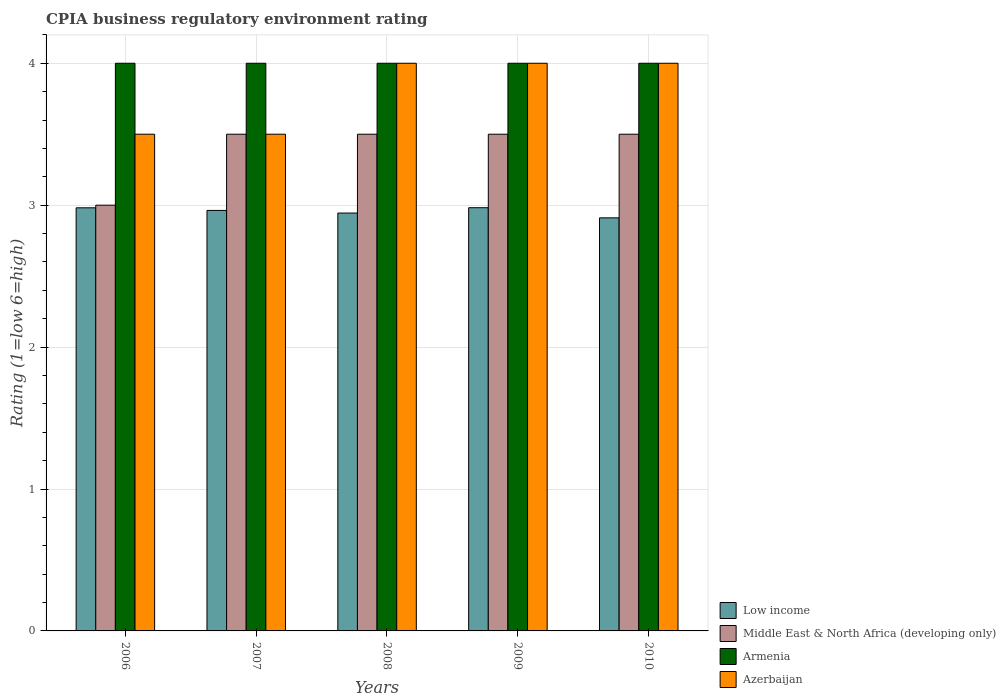How many different coloured bars are there?
Provide a succinct answer. 4. How many groups of bars are there?
Keep it short and to the point. 5. How many bars are there on the 1st tick from the left?
Your answer should be very brief. 4. What is the CPIA rating in Azerbaijan in 2010?
Your answer should be compact. 4. Across all years, what is the minimum CPIA rating in Middle East & North Africa (developing only)?
Your answer should be compact. 3. In which year was the CPIA rating in Azerbaijan maximum?
Provide a succinct answer. 2008. What is the total CPIA rating in Azerbaijan in the graph?
Your response must be concise. 19. What is the difference between the CPIA rating in Low income in 2007 and the CPIA rating in Middle East & North Africa (developing only) in 2010?
Offer a very short reply. -0.54. In the year 2006, what is the difference between the CPIA rating in Low income and CPIA rating in Middle East & North Africa (developing only)?
Provide a short and direct response. -0.02. What is the ratio of the CPIA rating in Azerbaijan in 2007 to that in 2010?
Give a very brief answer. 0.88. Is the difference between the CPIA rating in Low income in 2006 and 2007 greater than the difference between the CPIA rating in Middle East & North Africa (developing only) in 2006 and 2007?
Offer a terse response. Yes. What is the difference between the highest and the second highest CPIA rating in Low income?
Make the answer very short. 0. What does the 4th bar from the left in 2006 represents?
Provide a short and direct response. Azerbaijan. How many bars are there?
Provide a succinct answer. 20. Are all the bars in the graph horizontal?
Make the answer very short. No. How many years are there in the graph?
Give a very brief answer. 5. What is the difference between two consecutive major ticks on the Y-axis?
Offer a very short reply. 1. Are the values on the major ticks of Y-axis written in scientific E-notation?
Your answer should be very brief. No. What is the title of the graph?
Provide a short and direct response. CPIA business regulatory environment rating. What is the Rating (1=low 6=high) in Low income in 2006?
Your answer should be compact. 2.98. What is the Rating (1=low 6=high) in Armenia in 2006?
Give a very brief answer. 4. What is the Rating (1=low 6=high) of Low income in 2007?
Make the answer very short. 2.96. What is the Rating (1=low 6=high) in Middle East & North Africa (developing only) in 2007?
Make the answer very short. 3.5. What is the Rating (1=low 6=high) in Low income in 2008?
Ensure brevity in your answer.  2.94. What is the Rating (1=low 6=high) of Low income in 2009?
Provide a succinct answer. 2.98. What is the Rating (1=low 6=high) in Middle East & North Africa (developing only) in 2009?
Offer a terse response. 3.5. What is the Rating (1=low 6=high) of Azerbaijan in 2009?
Offer a very short reply. 4. What is the Rating (1=low 6=high) of Low income in 2010?
Ensure brevity in your answer.  2.91. Across all years, what is the maximum Rating (1=low 6=high) of Low income?
Keep it short and to the point. 2.98. Across all years, what is the maximum Rating (1=low 6=high) of Middle East & North Africa (developing only)?
Provide a succinct answer. 3.5. Across all years, what is the maximum Rating (1=low 6=high) of Armenia?
Your answer should be very brief. 4. Across all years, what is the minimum Rating (1=low 6=high) in Low income?
Your answer should be very brief. 2.91. Across all years, what is the minimum Rating (1=low 6=high) in Middle East & North Africa (developing only)?
Offer a very short reply. 3. What is the total Rating (1=low 6=high) of Low income in the graph?
Ensure brevity in your answer.  14.78. What is the total Rating (1=low 6=high) of Middle East & North Africa (developing only) in the graph?
Provide a short and direct response. 17. What is the total Rating (1=low 6=high) in Azerbaijan in the graph?
Offer a terse response. 19. What is the difference between the Rating (1=low 6=high) in Low income in 2006 and that in 2007?
Make the answer very short. 0.02. What is the difference between the Rating (1=low 6=high) of Middle East & North Africa (developing only) in 2006 and that in 2007?
Ensure brevity in your answer.  -0.5. What is the difference between the Rating (1=low 6=high) in Armenia in 2006 and that in 2007?
Your answer should be compact. 0. What is the difference between the Rating (1=low 6=high) of Low income in 2006 and that in 2008?
Provide a short and direct response. 0.04. What is the difference between the Rating (1=low 6=high) in Azerbaijan in 2006 and that in 2008?
Offer a very short reply. -0.5. What is the difference between the Rating (1=low 6=high) of Low income in 2006 and that in 2009?
Give a very brief answer. -0. What is the difference between the Rating (1=low 6=high) of Middle East & North Africa (developing only) in 2006 and that in 2009?
Offer a terse response. -0.5. What is the difference between the Rating (1=low 6=high) in Armenia in 2006 and that in 2009?
Provide a short and direct response. 0. What is the difference between the Rating (1=low 6=high) in Low income in 2006 and that in 2010?
Ensure brevity in your answer.  0.07. What is the difference between the Rating (1=low 6=high) of Low income in 2007 and that in 2008?
Give a very brief answer. 0.02. What is the difference between the Rating (1=low 6=high) of Middle East & North Africa (developing only) in 2007 and that in 2008?
Give a very brief answer. 0. What is the difference between the Rating (1=low 6=high) in Azerbaijan in 2007 and that in 2008?
Offer a terse response. -0.5. What is the difference between the Rating (1=low 6=high) of Low income in 2007 and that in 2009?
Make the answer very short. -0.02. What is the difference between the Rating (1=low 6=high) of Middle East & North Africa (developing only) in 2007 and that in 2009?
Provide a short and direct response. 0. What is the difference between the Rating (1=low 6=high) of Armenia in 2007 and that in 2009?
Ensure brevity in your answer.  0. What is the difference between the Rating (1=low 6=high) of Azerbaijan in 2007 and that in 2009?
Keep it short and to the point. -0.5. What is the difference between the Rating (1=low 6=high) in Low income in 2007 and that in 2010?
Your answer should be compact. 0.05. What is the difference between the Rating (1=low 6=high) of Low income in 2008 and that in 2009?
Your response must be concise. -0.04. What is the difference between the Rating (1=low 6=high) of Low income in 2008 and that in 2010?
Give a very brief answer. 0.03. What is the difference between the Rating (1=low 6=high) of Low income in 2009 and that in 2010?
Provide a succinct answer. 0.07. What is the difference between the Rating (1=low 6=high) in Middle East & North Africa (developing only) in 2009 and that in 2010?
Provide a succinct answer. 0. What is the difference between the Rating (1=low 6=high) in Azerbaijan in 2009 and that in 2010?
Provide a short and direct response. 0. What is the difference between the Rating (1=low 6=high) of Low income in 2006 and the Rating (1=low 6=high) of Middle East & North Africa (developing only) in 2007?
Provide a short and direct response. -0.52. What is the difference between the Rating (1=low 6=high) in Low income in 2006 and the Rating (1=low 6=high) in Armenia in 2007?
Your answer should be compact. -1.02. What is the difference between the Rating (1=low 6=high) of Low income in 2006 and the Rating (1=low 6=high) of Azerbaijan in 2007?
Provide a succinct answer. -0.52. What is the difference between the Rating (1=low 6=high) in Middle East & North Africa (developing only) in 2006 and the Rating (1=low 6=high) in Armenia in 2007?
Ensure brevity in your answer.  -1. What is the difference between the Rating (1=low 6=high) of Armenia in 2006 and the Rating (1=low 6=high) of Azerbaijan in 2007?
Offer a very short reply. 0.5. What is the difference between the Rating (1=low 6=high) in Low income in 2006 and the Rating (1=low 6=high) in Middle East & North Africa (developing only) in 2008?
Your response must be concise. -0.52. What is the difference between the Rating (1=low 6=high) in Low income in 2006 and the Rating (1=low 6=high) in Armenia in 2008?
Provide a short and direct response. -1.02. What is the difference between the Rating (1=low 6=high) of Low income in 2006 and the Rating (1=low 6=high) of Azerbaijan in 2008?
Offer a very short reply. -1.02. What is the difference between the Rating (1=low 6=high) of Middle East & North Africa (developing only) in 2006 and the Rating (1=low 6=high) of Azerbaijan in 2008?
Your answer should be very brief. -1. What is the difference between the Rating (1=low 6=high) in Low income in 2006 and the Rating (1=low 6=high) in Middle East & North Africa (developing only) in 2009?
Your answer should be compact. -0.52. What is the difference between the Rating (1=low 6=high) of Low income in 2006 and the Rating (1=low 6=high) of Armenia in 2009?
Ensure brevity in your answer.  -1.02. What is the difference between the Rating (1=low 6=high) of Low income in 2006 and the Rating (1=low 6=high) of Azerbaijan in 2009?
Offer a very short reply. -1.02. What is the difference between the Rating (1=low 6=high) of Armenia in 2006 and the Rating (1=low 6=high) of Azerbaijan in 2009?
Offer a terse response. 0. What is the difference between the Rating (1=low 6=high) in Low income in 2006 and the Rating (1=low 6=high) in Middle East & North Africa (developing only) in 2010?
Your response must be concise. -0.52. What is the difference between the Rating (1=low 6=high) of Low income in 2006 and the Rating (1=low 6=high) of Armenia in 2010?
Provide a short and direct response. -1.02. What is the difference between the Rating (1=low 6=high) in Low income in 2006 and the Rating (1=low 6=high) in Azerbaijan in 2010?
Your answer should be very brief. -1.02. What is the difference between the Rating (1=low 6=high) in Middle East & North Africa (developing only) in 2006 and the Rating (1=low 6=high) in Armenia in 2010?
Keep it short and to the point. -1. What is the difference between the Rating (1=low 6=high) of Middle East & North Africa (developing only) in 2006 and the Rating (1=low 6=high) of Azerbaijan in 2010?
Ensure brevity in your answer.  -1. What is the difference between the Rating (1=low 6=high) of Armenia in 2006 and the Rating (1=low 6=high) of Azerbaijan in 2010?
Your response must be concise. 0. What is the difference between the Rating (1=low 6=high) in Low income in 2007 and the Rating (1=low 6=high) in Middle East & North Africa (developing only) in 2008?
Your response must be concise. -0.54. What is the difference between the Rating (1=low 6=high) in Low income in 2007 and the Rating (1=low 6=high) in Armenia in 2008?
Ensure brevity in your answer.  -1.04. What is the difference between the Rating (1=low 6=high) in Low income in 2007 and the Rating (1=low 6=high) in Azerbaijan in 2008?
Ensure brevity in your answer.  -1.04. What is the difference between the Rating (1=low 6=high) of Middle East & North Africa (developing only) in 2007 and the Rating (1=low 6=high) of Armenia in 2008?
Give a very brief answer. -0.5. What is the difference between the Rating (1=low 6=high) of Armenia in 2007 and the Rating (1=low 6=high) of Azerbaijan in 2008?
Provide a succinct answer. 0. What is the difference between the Rating (1=low 6=high) of Low income in 2007 and the Rating (1=low 6=high) of Middle East & North Africa (developing only) in 2009?
Give a very brief answer. -0.54. What is the difference between the Rating (1=low 6=high) of Low income in 2007 and the Rating (1=low 6=high) of Armenia in 2009?
Ensure brevity in your answer.  -1.04. What is the difference between the Rating (1=low 6=high) of Low income in 2007 and the Rating (1=low 6=high) of Azerbaijan in 2009?
Offer a terse response. -1.04. What is the difference between the Rating (1=low 6=high) of Middle East & North Africa (developing only) in 2007 and the Rating (1=low 6=high) of Armenia in 2009?
Offer a terse response. -0.5. What is the difference between the Rating (1=low 6=high) in Middle East & North Africa (developing only) in 2007 and the Rating (1=low 6=high) in Azerbaijan in 2009?
Offer a terse response. -0.5. What is the difference between the Rating (1=low 6=high) in Armenia in 2007 and the Rating (1=low 6=high) in Azerbaijan in 2009?
Provide a short and direct response. 0. What is the difference between the Rating (1=low 6=high) of Low income in 2007 and the Rating (1=low 6=high) of Middle East & North Africa (developing only) in 2010?
Provide a short and direct response. -0.54. What is the difference between the Rating (1=low 6=high) in Low income in 2007 and the Rating (1=low 6=high) in Armenia in 2010?
Your answer should be very brief. -1.04. What is the difference between the Rating (1=low 6=high) in Low income in 2007 and the Rating (1=low 6=high) in Azerbaijan in 2010?
Your response must be concise. -1.04. What is the difference between the Rating (1=low 6=high) in Middle East & North Africa (developing only) in 2007 and the Rating (1=low 6=high) in Azerbaijan in 2010?
Your answer should be very brief. -0.5. What is the difference between the Rating (1=low 6=high) of Low income in 2008 and the Rating (1=low 6=high) of Middle East & North Africa (developing only) in 2009?
Your response must be concise. -0.56. What is the difference between the Rating (1=low 6=high) of Low income in 2008 and the Rating (1=low 6=high) of Armenia in 2009?
Provide a short and direct response. -1.06. What is the difference between the Rating (1=low 6=high) of Low income in 2008 and the Rating (1=low 6=high) of Azerbaijan in 2009?
Provide a succinct answer. -1.06. What is the difference between the Rating (1=low 6=high) of Middle East & North Africa (developing only) in 2008 and the Rating (1=low 6=high) of Armenia in 2009?
Provide a short and direct response. -0.5. What is the difference between the Rating (1=low 6=high) of Middle East & North Africa (developing only) in 2008 and the Rating (1=low 6=high) of Azerbaijan in 2009?
Make the answer very short. -0.5. What is the difference between the Rating (1=low 6=high) of Armenia in 2008 and the Rating (1=low 6=high) of Azerbaijan in 2009?
Your response must be concise. 0. What is the difference between the Rating (1=low 6=high) in Low income in 2008 and the Rating (1=low 6=high) in Middle East & North Africa (developing only) in 2010?
Your answer should be compact. -0.56. What is the difference between the Rating (1=low 6=high) of Low income in 2008 and the Rating (1=low 6=high) of Armenia in 2010?
Offer a very short reply. -1.06. What is the difference between the Rating (1=low 6=high) of Low income in 2008 and the Rating (1=low 6=high) of Azerbaijan in 2010?
Offer a very short reply. -1.06. What is the difference between the Rating (1=low 6=high) of Middle East & North Africa (developing only) in 2008 and the Rating (1=low 6=high) of Armenia in 2010?
Keep it short and to the point. -0.5. What is the difference between the Rating (1=low 6=high) of Middle East & North Africa (developing only) in 2008 and the Rating (1=low 6=high) of Azerbaijan in 2010?
Keep it short and to the point. -0.5. What is the difference between the Rating (1=low 6=high) in Armenia in 2008 and the Rating (1=low 6=high) in Azerbaijan in 2010?
Make the answer very short. 0. What is the difference between the Rating (1=low 6=high) of Low income in 2009 and the Rating (1=low 6=high) of Middle East & North Africa (developing only) in 2010?
Provide a short and direct response. -0.52. What is the difference between the Rating (1=low 6=high) of Low income in 2009 and the Rating (1=low 6=high) of Armenia in 2010?
Offer a very short reply. -1.02. What is the difference between the Rating (1=low 6=high) in Low income in 2009 and the Rating (1=low 6=high) in Azerbaijan in 2010?
Ensure brevity in your answer.  -1.02. What is the difference between the Rating (1=low 6=high) in Middle East & North Africa (developing only) in 2009 and the Rating (1=low 6=high) in Armenia in 2010?
Keep it short and to the point. -0.5. What is the difference between the Rating (1=low 6=high) in Middle East & North Africa (developing only) in 2009 and the Rating (1=low 6=high) in Azerbaijan in 2010?
Provide a succinct answer. -0.5. What is the average Rating (1=low 6=high) of Low income per year?
Keep it short and to the point. 2.96. What is the average Rating (1=low 6=high) of Armenia per year?
Offer a very short reply. 4. What is the average Rating (1=low 6=high) in Azerbaijan per year?
Offer a very short reply. 3.8. In the year 2006, what is the difference between the Rating (1=low 6=high) of Low income and Rating (1=low 6=high) of Middle East & North Africa (developing only)?
Your answer should be very brief. -0.02. In the year 2006, what is the difference between the Rating (1=low 6=high) in Low income and Rating (1=low 6=high) in Armenia?
Your answer should be compact. -1.02. In the year 2006, what is the difference between the Rating (1=low 6=high) of Low income and Rating (1=low 6=high) of Azerbaijan?
Keep it short and to the point. -0.52. In the year 2006, what is the difference between the Rating (1=low 6=high) in Middle East & North Africa (developing only) and Rating (1=low 6=high) in Armenia?
Your answer should be very brief. -1. In the year 2006, what is the difference between the Rating (1=low 6=high) of Middle East & North Africa (developing only) and Rating (1=low 6=high) of Azerbaijan?
Give a very brief answer. -0.5. In the year 2006, what is the difference between the Rating (1=low 6=high) of Armenia and Rating (1=low 6=high) of Azerbaijan?
Keep it short and to the point. 0.5. In the year 2007, what is the difference between the Rating (1=low 6=high) in Low income and Rating (1=low 6=high) in Middle East & North Africa (developing only)?
Give a very brief answer. -0.54. In the year 2007, what is the difference between the Rating (1=low 6=high) in Low income and Rating (1=low 6=high) in Armenia?
Ensure brevity in your answer.  -1.04. In the year 2007, what is the difference between the Rating (1=low 6=high) of Low income and Rating (1=low 6=high) of Azerbaijan?
Keep it short and to the point. -0.54. In the year 2007, what is the difference between the Rating (1=low 6=high) in Middle East & North Africa (developing only) and Rating (1=low 6=high) in Armenia?
Provide a succinct answer. -0.5. In the year 2007, what is the difference between the Rating (1=low 6=high) of Middle East & North Africa (developing only) and Rating (1=low 6=high) of Azerbaijan?
Keep it short and to the point. 0. In the year 2008, what is the difference between the Rating (1=low 6=high) of Low income and Rating (1=low 6=high) of Middle East & North Africa (developing only)?
Your response must be concise. -0.56. In the year 2008, what is the difference between the Rating (1=low 6=high) in Low income and Rating (1=low 6=high) in Armenia?
Provide a short and direct response. -1.06. In the year 2008, what is the difference between the Rating (1=low 6=high) in Low income and Rating (1=low 6=high) in Azerbaijan?
Your answer should be compact. -1.06. In the year 2008, what is the difference between the Rating (1=low 6=high) of Middle East & North Africa (developing only) and Rating (1=low 6=high) of Azerbaijan?
Your answer should be very brief. -0.5. In the year 2009, what is the difference between the Rating (1=low 6=high) in Low income and Rating (1=low 6=high) in Middle East & North Africa (developing only)?
Keep it short and to the point. -0.52. In the year 2009, what is the difference between the Rating (1=low 6=high) of Low income and Rating (1=low 6=high) of Armenia?
Your answer should be very brief. -1.02. In the year 2009, what is the difference between the Rating (1=low 6=high) in Low income and Rating (1=low 6=high) in Azerbaijan?
Ensure brevity in your answer.  -1.02. In the year 2009, what is the difference between the Rating (1=low 6=high) in Middle East & North Africa (developing only) and Rating (1=low 6=high) in Azerbaijan?
Provide a short and direct response. -0.5. In the year 2010, what is the difference between the Rating (1=low 6=high) in Low income and Rating (1=low 6=high) in Middle East & North Africa (developing only)?
Give a very brief answer. -0.59. In the year 2010, what is the difference between the Rating (1=low 6=high) of Low income and Rating (1=low 6=high) of Armenia?
Offer a terse response. -1.09. In the year 2010, what is the difference between the Rating (1=low 6=high) of Low income and Rating (1=low 6=high) of Azerbaijan?
Provide a succinct answer. -1.09. In the year 2010, what is the difference between the Rating (1=low 6=high) of Middle East & North Africa (developing only) and Rating (1=low 6=high) of Azerbaijan?
Ensure brevity in your answer.  -0.5. What is the ratio of the Rating (1=low 6=high) in Middle East & North Africa (developing only) in 2006 to that in 2007?
Ensure brevity in your answer.  0.86. What is the ratio of the Rating (1=low 6=high) of Armenia in 2006 to that in 2007?
Provide a succinct answer. 1. What is the ratio of the Rating (1=low 6=high) of Low income in 2006 to that in 2008?
Your answer should be very brief. 1.01. What is the ratio of the Rating (1=low 6=high) of Armenia in 2006 to that in 2008?
Give a very brief answer. 1. What is the ratio of the Rating (1=low 6=high) in Low income in 2006 to that in 2009?
Make the answer very short. 1. What is the ratio of the Rating (1=low 6=high) in Low income in 2006 to that in 2010?
Make the answer very short. 1.02. What is the ratio of the Rating (1=low 6=high) in Middle East & North Africa (developing only) in 2006 to that in 2010?
Provide a succinct answer. 0.86. What is the ratio of the Rating (1=low 6=high) of Azerbaijan in 2006 to that in 2010?
Make the answer very short. 0.88. What is the ratio of the Rating (1=low 6=high) of Low income in 2007 to that in 2008?
Offer a very short reply. 1.01. What is the ratio of the Rating (1=low 6=high) in Middle East & North Africa (developing only) in 2007 to that in 2008?
Your answer should be very brief. 1. What is the ratio of the Rating (1=low 6=high) in Armenia in 2007 to that in 2008?
Keep it short and to the point. 1. What is the ratio of the Rating (1=low 6=high) in Low income in 2007 to that in 2009?
Provide a short and direct response. 0.99. What is the ratio of the Rating (1=low 6=high) of Armenia in 2007 to that in 2009?
Offer a terse response. 1. What is the ratio of the Rating (1=low 6=high) in Middle East & North Africa (developing only) in 2007 to that in 2010?
Your answer should be compact. 1. What is the ratio of the Rating (1=low 6=high) of Armenia in 2007 to that in 2010?
Offer a terse response. 1. What is the ratio of the Rating (1=low 6=high) of Azerbaijan in 2007 to that in 2010?
Offer a terse response. 0.88. What is the ratio of the Rating (1=low 6=high) in Low income in 2008 to that in 2009?
Ensure brevity in your answer.  0.99. What is the ratio of the Rating (1=low 6=high) of Middle East & North Africa (developing only) in 2008 to that in 2009?
Your answer should be compact. 1. What is the ratio of the Rating (1=low 6=high) of Armenia in 2008 to that in 2009?
Your response must be concise. 1. What is the ratio of the Rating (1=low 6=high) in Azerbaijan in 2008 to that in 2009?
Give a very brief answer. 1. What is the ratio of the Rating (1=low 6=high) in Low income in 2008 to that in 2010?
Offer a very short reply. 1.01. What is the ratio of the Rating (1=low 6=high) in Middle East & North Africa (developing only) in 2008 to that in 2010?
Your answer should be compact. 1. What is the ratio of the Rating (1=low 6=high) of Armenia in 2008 to that in 2010?
Your answer should be very brief. 1. What is the ratio of the Rating (1=low 6=high) in Azerbaijan in 2008 to that in 2010?
Your answer should be very brief. 1. What is the ratio of the Rating (1=low 6=high) in Low income in 2009 to that in 2010?
Offer a very short reply. 1.02. What is the ratio of the Rating (1=low 6=high) of Armenia in 2009 to that in 2010?
Provide a succinct answer. 1. What is the ratio of the Rating (1=low 6=high) in Azerbaijan in 2009 to that in 2010?
Make the answer very short. 1. What is the difference between the highest and the second highest Rating (1=low 6=high) of Low income?
Give a very brief answer. 0. What is the difference between the highest and the second highest Rating (1=low 6=high) in Middle East & North Africa (developing only)?
Your response must be concise. 0. What is the difference between the highest and the lowest Rating (1=low 6=high) of Low income?
Ensure brevity in your answer.  0.07. What is the difference between the highest and the lowest Rating (1=low 6=high) of Armenia?
Make the answer very short. 0. What is the difference between the highest and the lowest Rating (1=low 6=high) of Azerbaijan?
Provide a succinct answer. 0.5. 